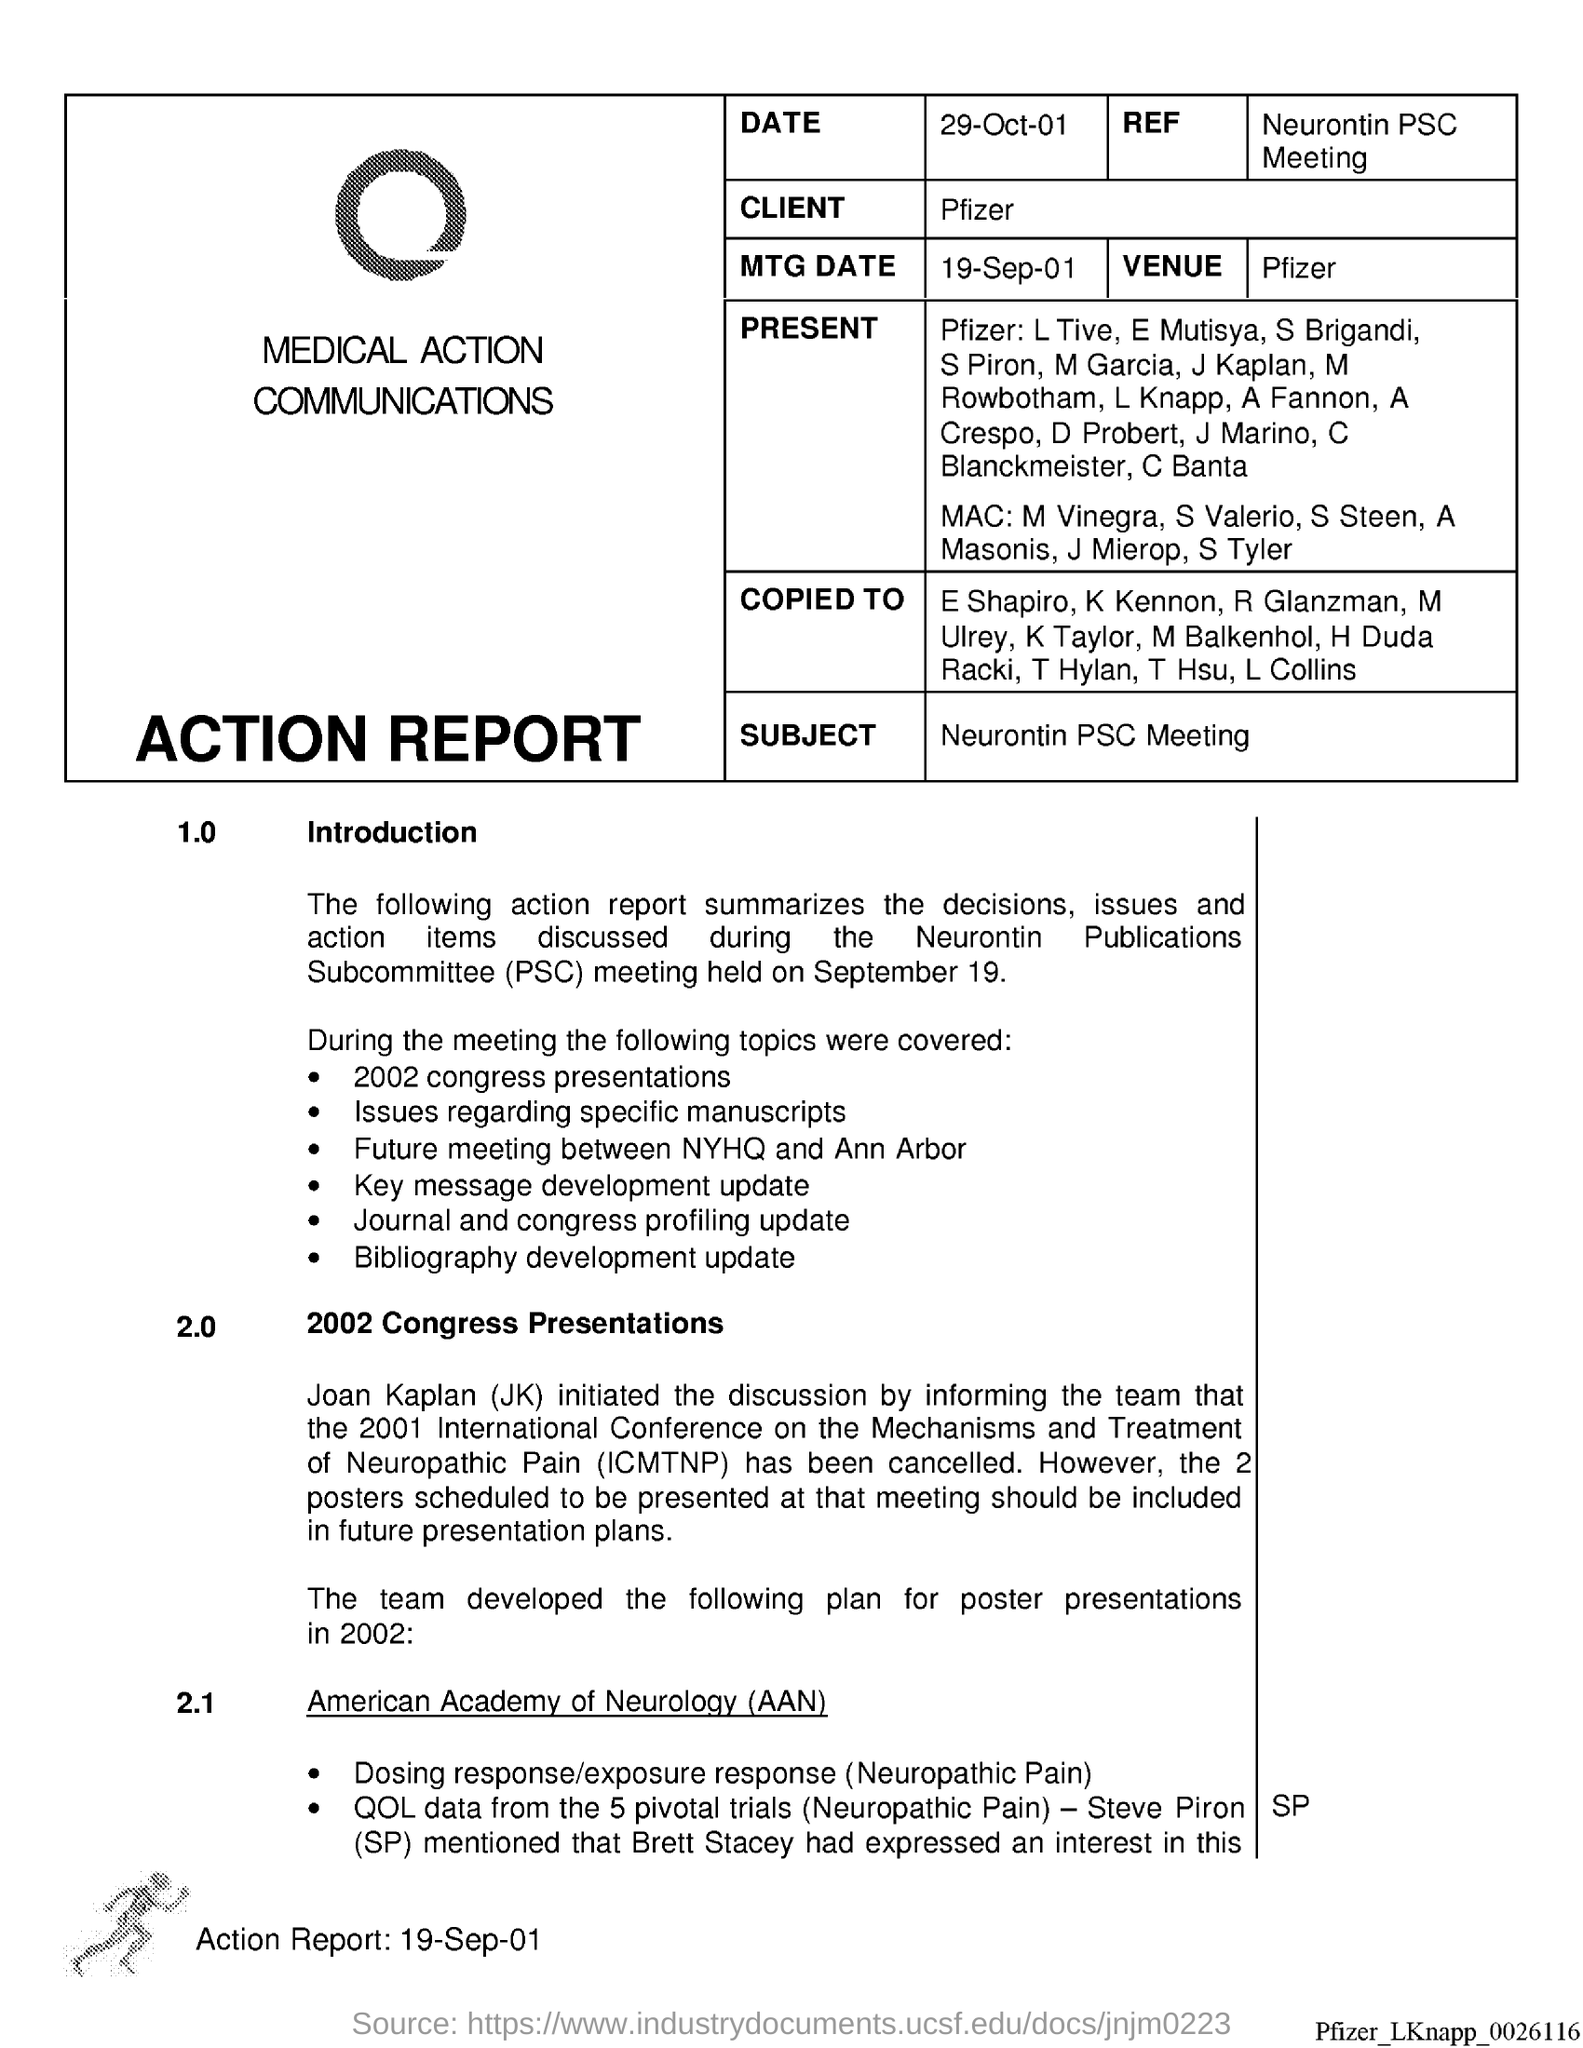Give some essential details in this illustration. What does 'SP' stand for when used as a name, such as in the case of Steve Piron? The MTG Date in Action report is a document that provides information about a specific date, such as September 19th, 2001. What is the date in the action report? It is 29th of October, 2001. The acronym PSC stands for Publications Subcommittee, which is a group responsible for overseeing and managing the publication of materials related to a particular subject or organization. The subject of the action report is the Neurontin PSC meeting. 